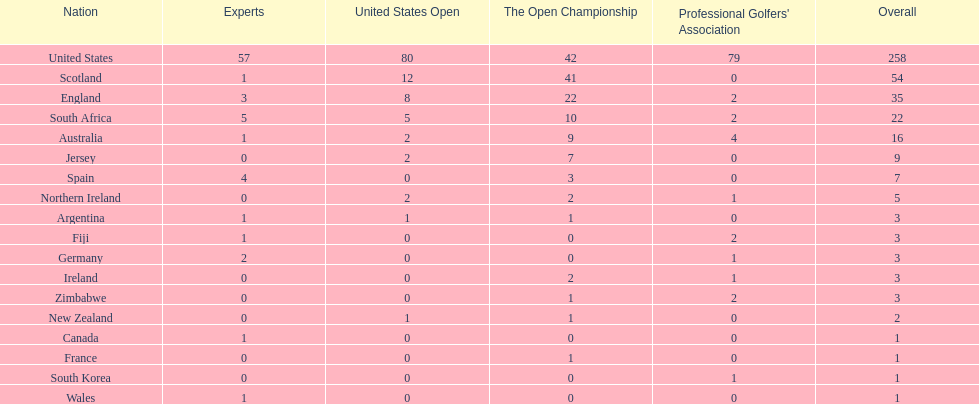How many countries have yielded the same quantity of championship golf players as canada? 3. 